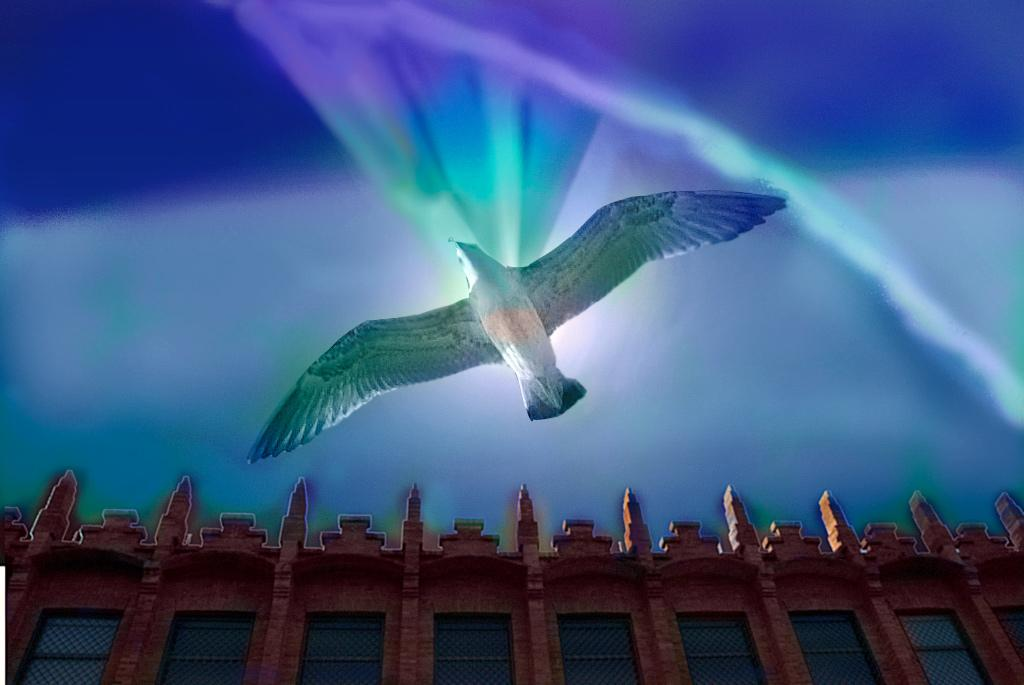What is happening in the sky in the image? There is a bird flying in the sky in the image. What can be seen at the bottom of the image? There is a building at the bottom of the image. What color is the sheep in the image? There is no sheep present in the image. How many stitches are visible on the bird in the image? The bird in the image is not a fabric or stitched object, so there are no stitches visible. 